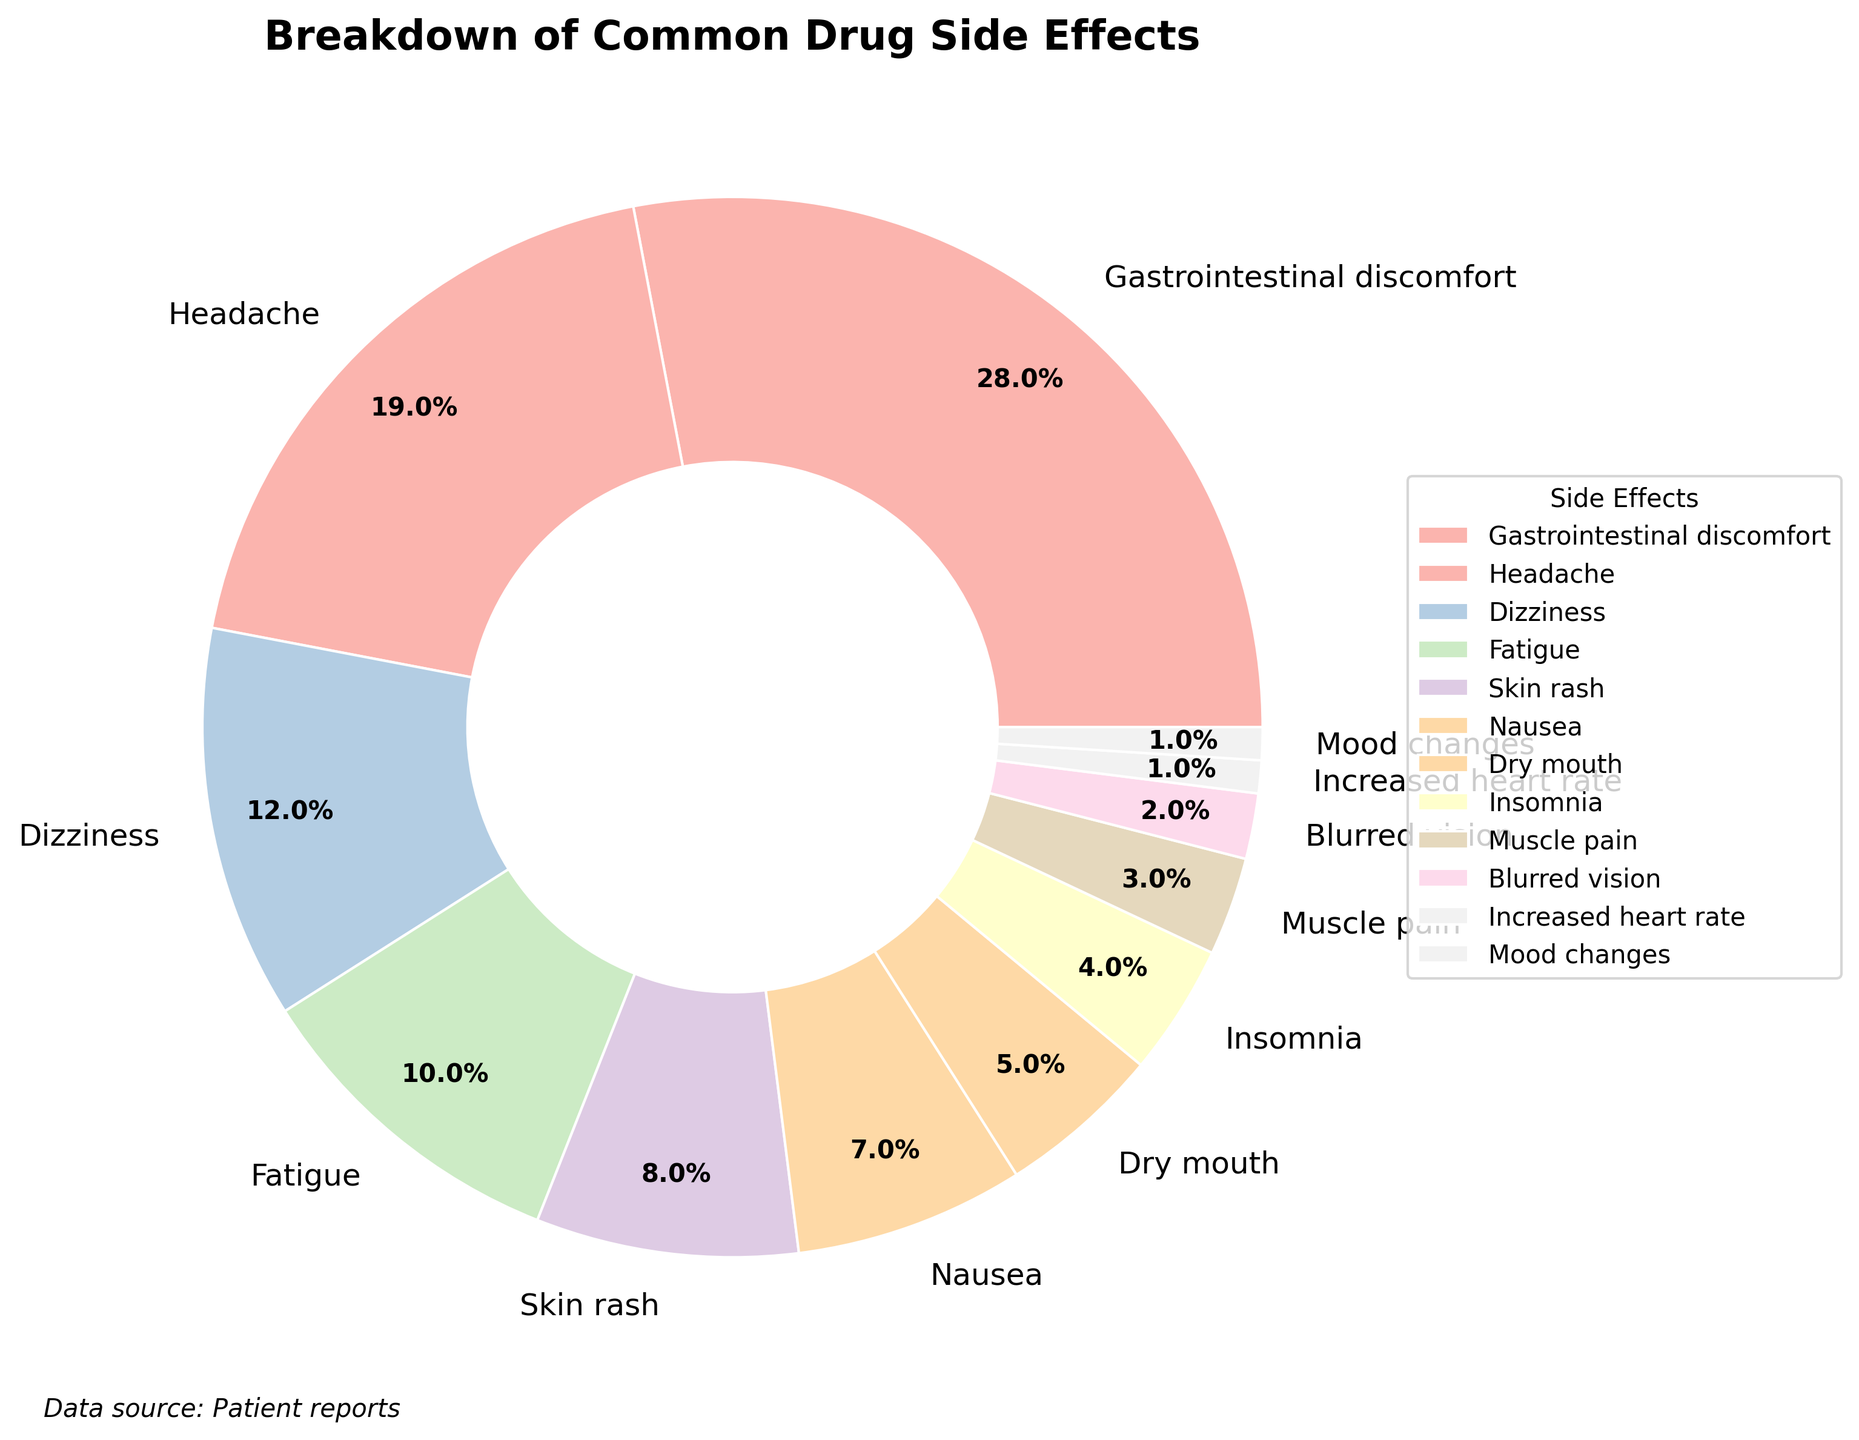Which side effect has the highest percentage? According to the pie chart, the side effect with the highest percentage is Gastrointestinal discomfort, showing 28%.
Answer: Gastrointestinal discomfort Which two side effects have the same percentage reported? From the pie chart, Mood changes and Increased heart rate both have a percentage of 1%.
Answer: Mood changes and Increased heart rate What is the total percentage of side effects reported for Dizziness, Fatigue, and Skin rash combined? The percentages for Dizziness, Fatigue, and Skin rash are 12%, 10%, and 8%, respectively. Adding these together yields 12% + 10% + 8% = 30%.
Answer: 30% How much higher is the percentage of Gastrointestinal discomfort compared to Headache? Gastrointestinal discomfort is 28% and Headache is 19%. The difference between them is 28% - 19% = 9%.
Answer: 9% Is the percentage of Muscle pain higher than that of Dry mouth? According to the pie chart, Muscle pain has a percentage of 3% and Dry mouth has 5%. Therefore, Muscle pain is not higher than Dry mouth.
Answer: No Which color is used to represent Fatigue in the pie chart? By examining the visual attributes of the pie chart, the wedge representing Fatigue is shown in a specific pastel color within the custom color palette used.
Answer: (Note: You will need to refer to the actual chart for the exact color) What is the combined percentage of the three least reported side effects? The three least reported side effects are Increased heart rate (1%), Mood changes (1%), and Blurred vision (2%). Adding these together yields 1% + 1% + 2% = 4%.
Answer: 4% Which side effect is represented by the most visually distinct wedge, and why? To answer this, refer to the pie chart and identify the largest wedge which stands out the most. Gastrointestinal discomfort has the largest wedge at 28%, making it the most visually distinct.
Answer: Gastrointestinal discomfort Among Gastrointestinal discomfort, Headache, and Dizziness, which side effect has the smallest reported percentage? From the given side effects (28%, 19%, 12%), Dizziness has the smallest reported percentage at 12%.
Answer: Dizziness What is the percentage difference between Insomnia and Nausea? Insomnia is reported at 4% and Nausea at 7%. The percentage difference between them is 7% - 4% = 3%.
Answer: 3% 